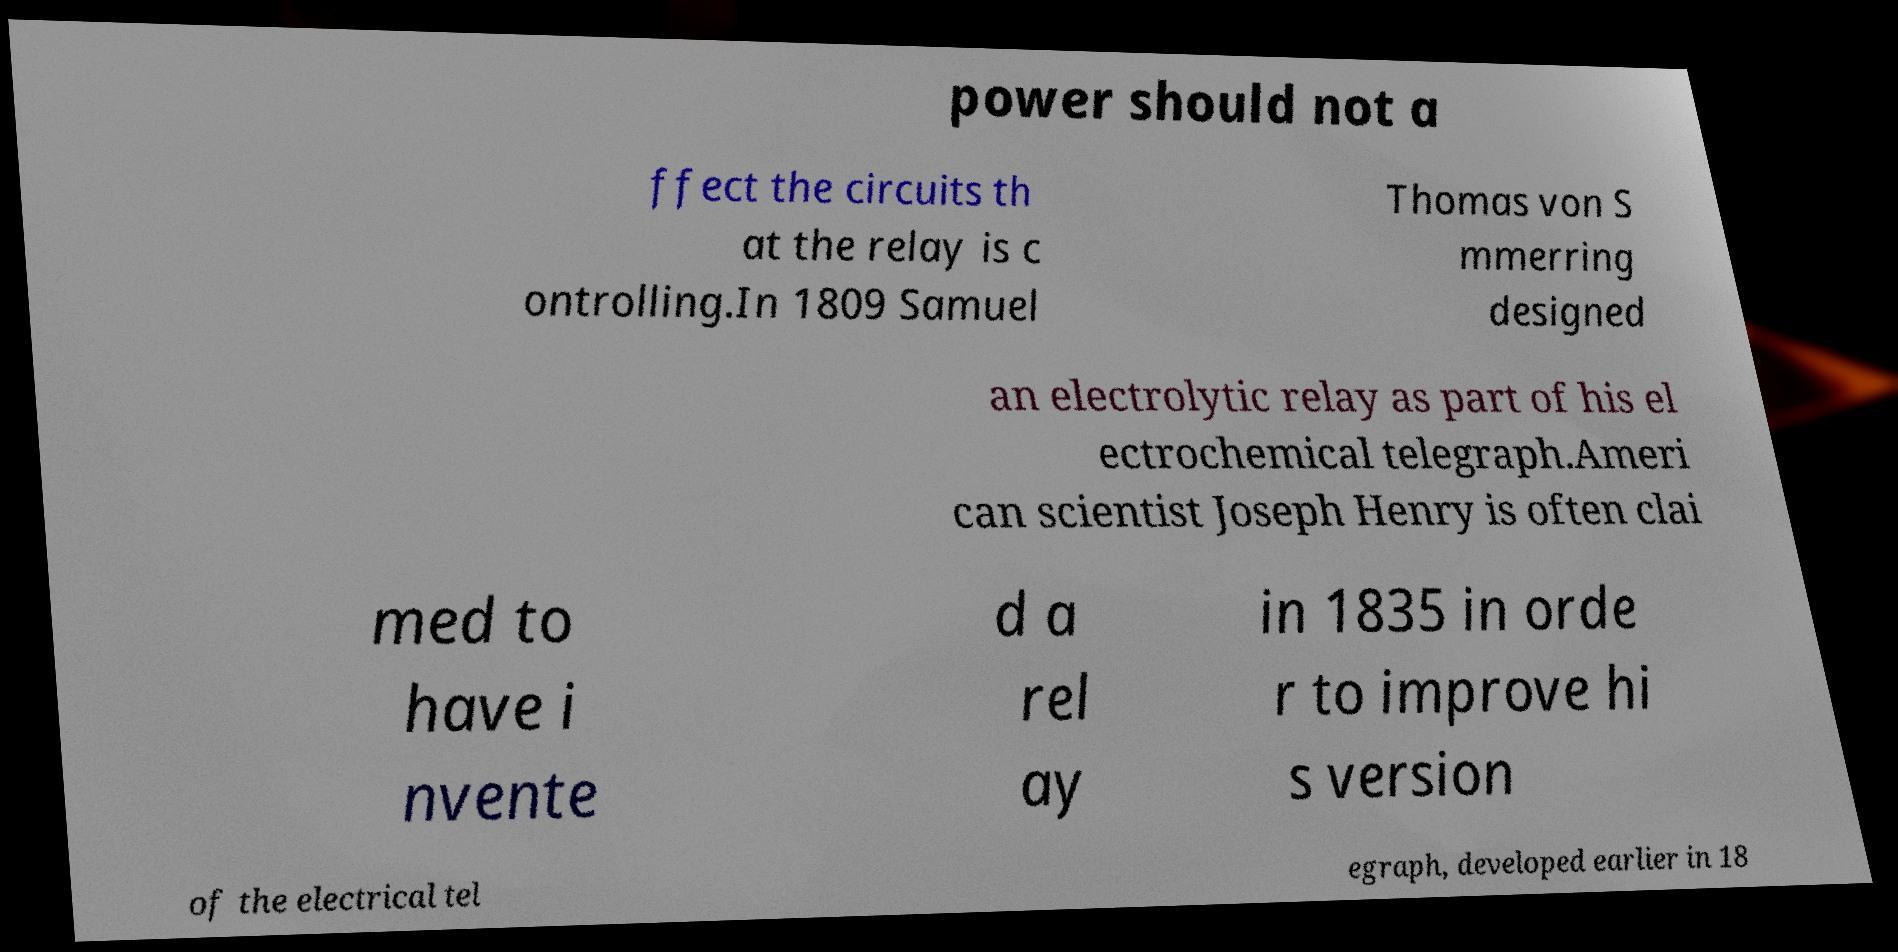Please identify and transcribe the text found in this image. power should not a ffect the circuits th at the relay is c ontrolling.In 1809 Samuel Thomas von S mmerring designed an electrolytic relay as part of his el ectrochemical telegraph.Ameri can scientist Joseph Henry is often clai med to have i nvente d a rel ay in 1835 in orde r to improve hi s version of the electrical tel egraph, developed earlier in 18 